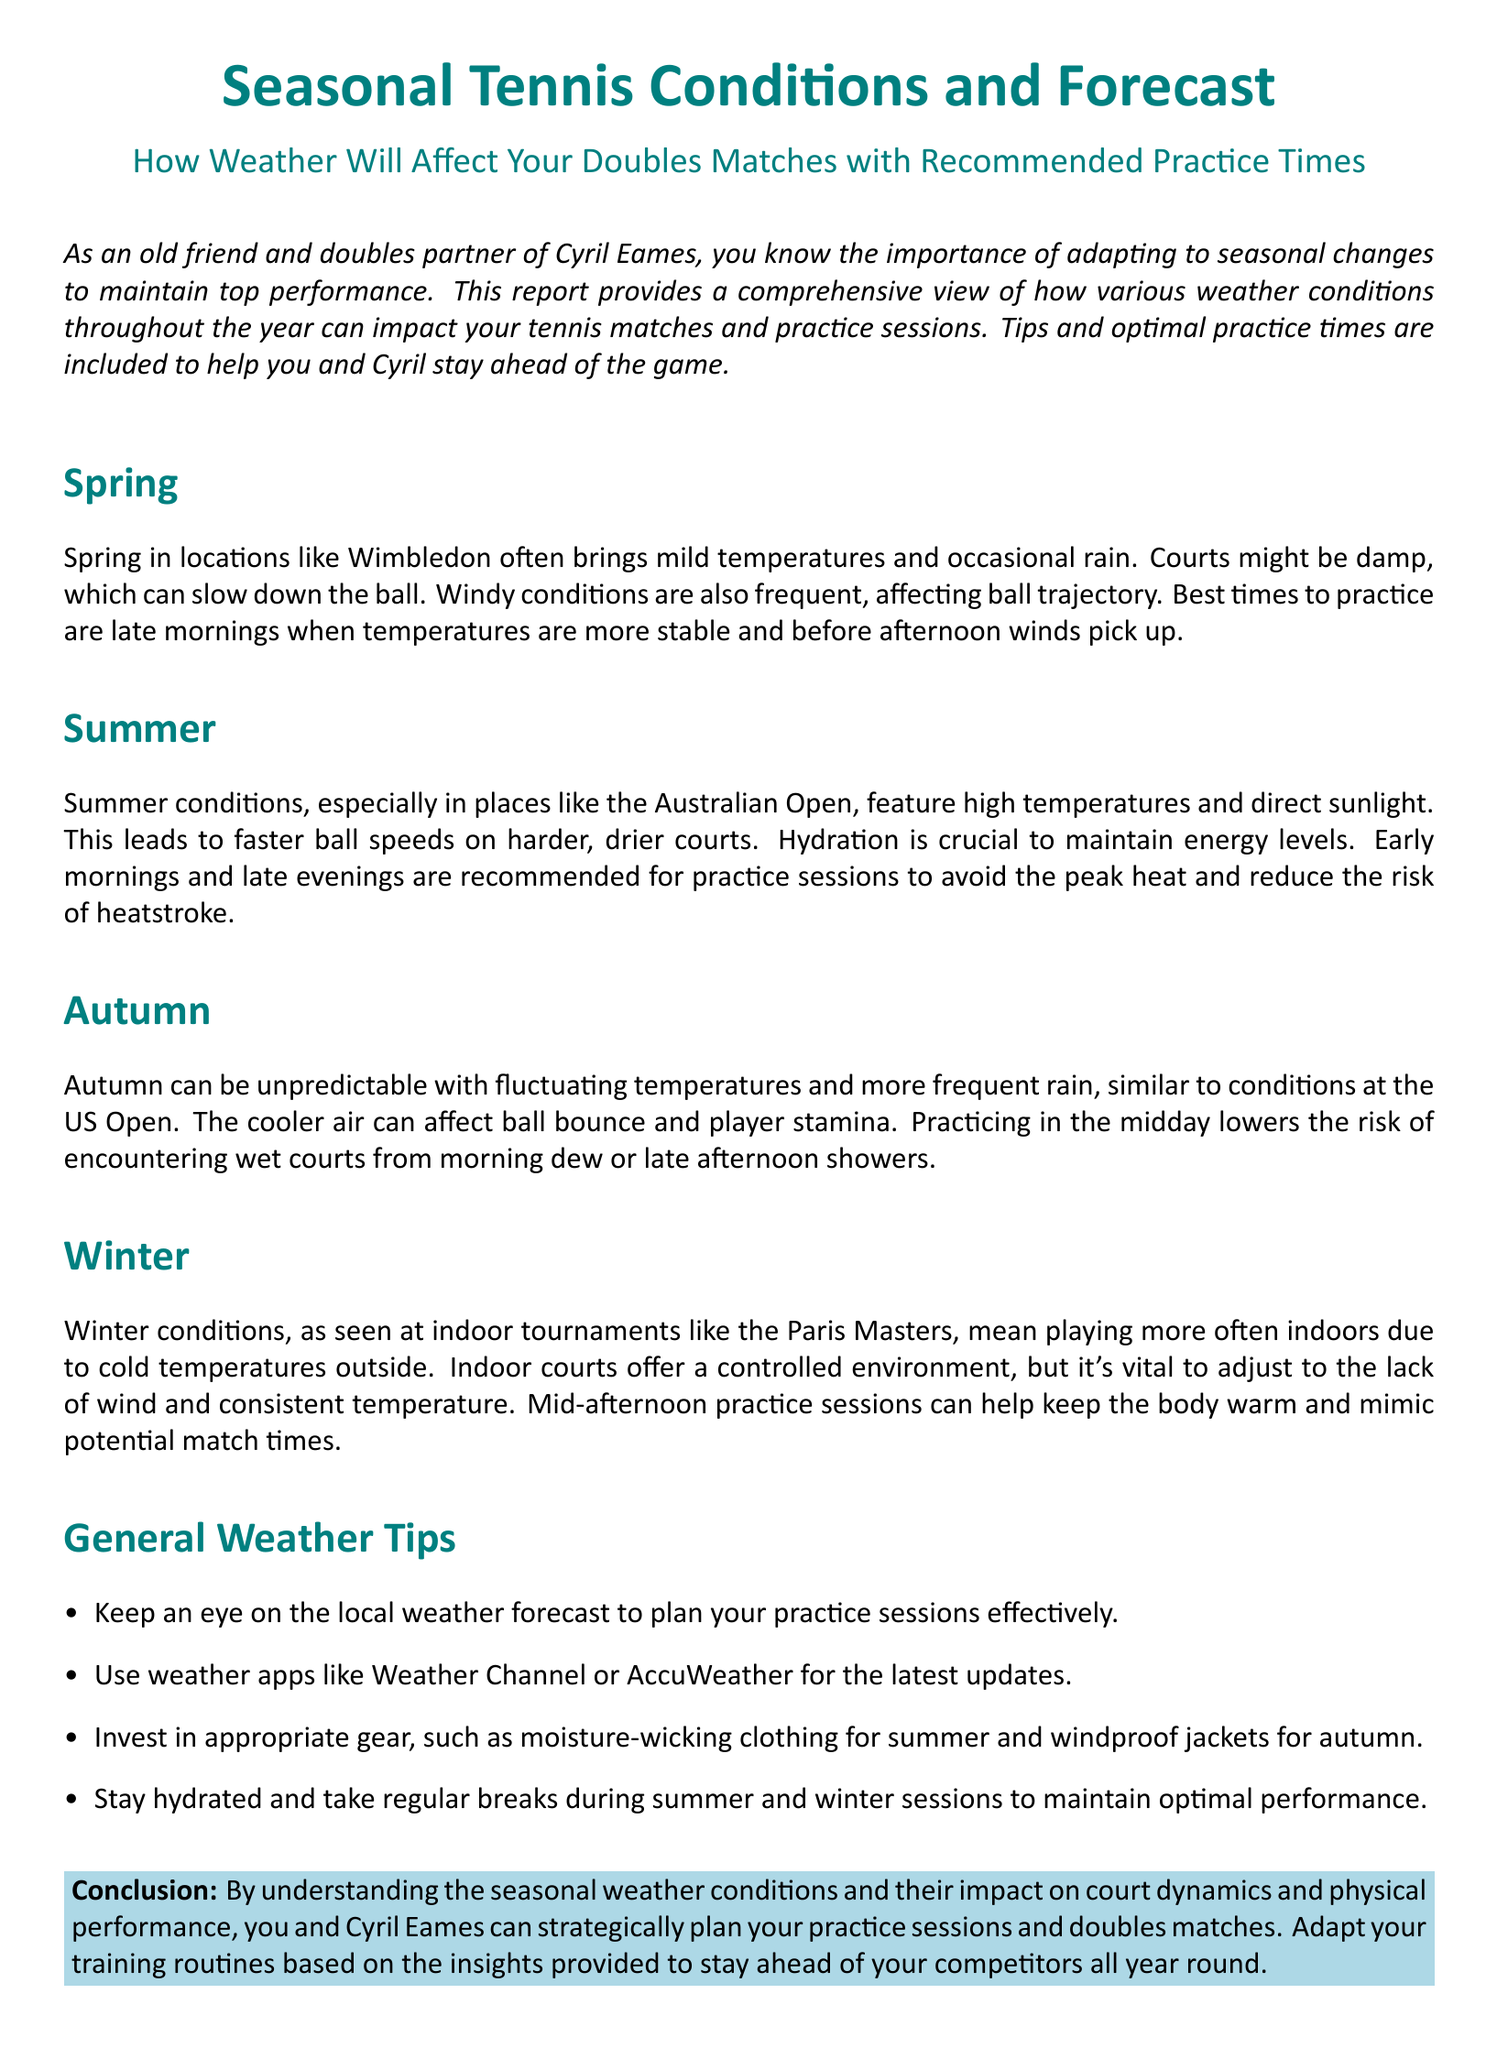What is the best time to practice in Spring? The report states that the best times to practice in Spring are late mornings.
Answer: Late mornings How does summer weather affect ball speed? The document mentions that summer conditions lead to faster ball speeds on harder, drier courts.
Answer: Faster ball speeds What should you be cautious of during summer practice sessions? It highlights the importance of hydration to maintain energy levels during summer.
Answer: Hydration When is the recommended practice time in Autumn? The report indicates that practicing in the midday is recommended to avoid wet courts.
Answer: Midday What environment is typical for Winter tennis? The document describes that Winter conditions often mean playing indoors due to cold temperatures.
Answer: Indoors What overall advice does the document provide for checking the weather? It suggests keeping an eye on the local weather forecast for planning practice sessions.
Answer: Local weather forecast What clothing is recommended for summer practices? The report advises investing in moisture-wicking clothing for summer.
Answer: Moisture-wicking clothing Which courts offer a controlled environment in Winter? The document states that indoor courts offer a controlled environment.
Answer: Indoor courts What is a common issue faced during Autumn tennis sessions? The report mentions that fluctuating temperatures and rain can be issues during Autumn.
Answer: Fluctuating temperatures and rain 